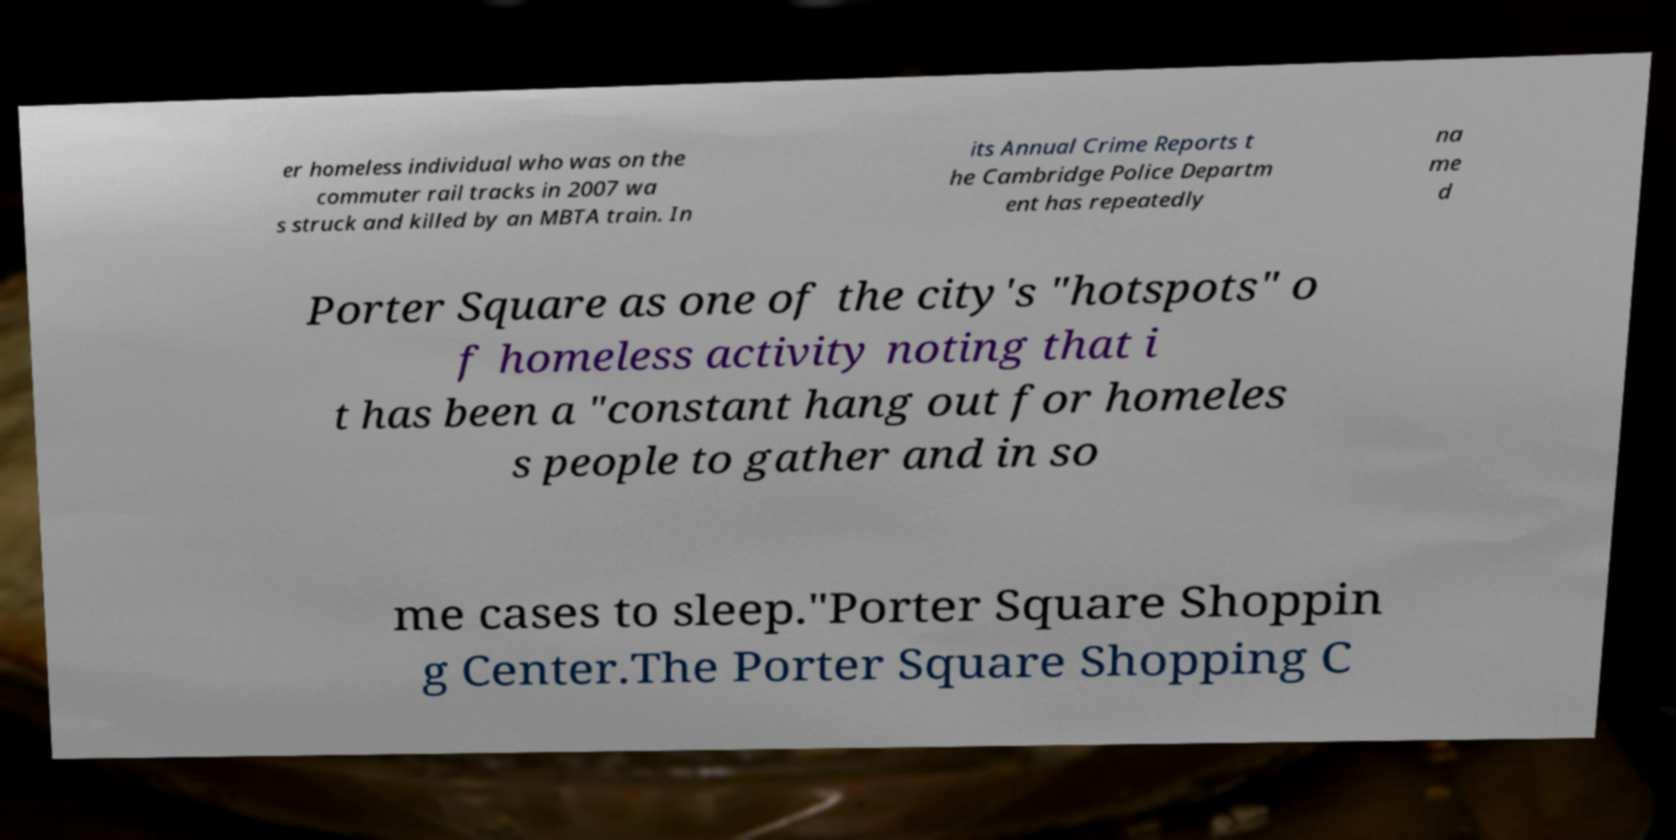What messages or text are displayed in this image? I need them in a readable, typed format. er homeless individual who was on the commuter rail tracks in 2007 wa s struck and killed by an MBTA train. In its Annual Crime Reports t he Cambridge Police Departm ent has repeatedly na me d Porter Square as one of the city's "hotspots" o f homeless activity noting that i t has been a "constant hang out for homeles s people to gather and in so me cases to sleep."Porter Square Shoppin g Center.The Porter Square Shopping C 